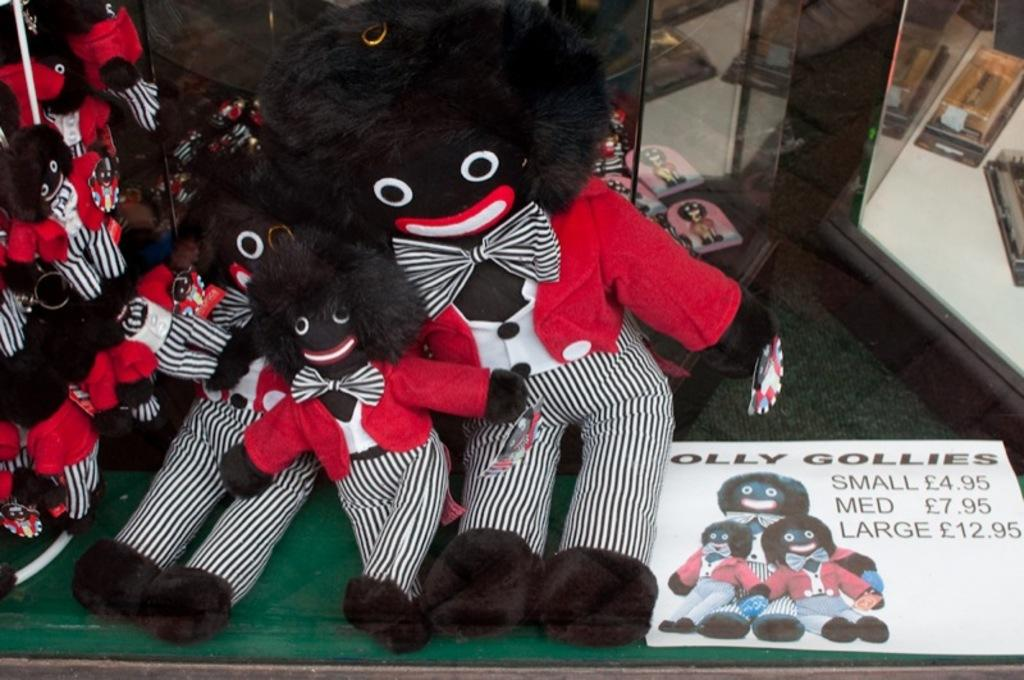What type of stuffed animals are in the image? There are Teddy bears in the image. What is on the floor in the image? There is a poster on the floor in the image. Can you describe the poster? The poster has images and text. What other objects can be seen in the image? There are other unspecified objects in the image. What type of snail can be seen crawling on the poster in the image? There is no snail present on the poster or in the image. How does the donkey feel about the Teddy bears in the image? There is no donkey present in the image, so it is not possible to determine how it might feel about the Teddy bears. 